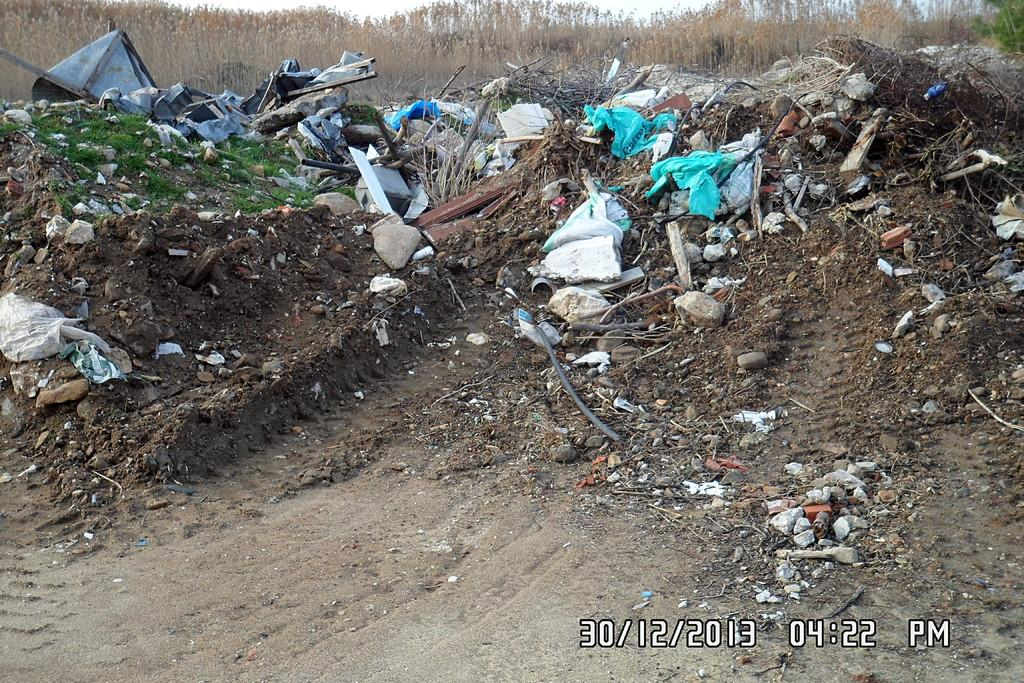What is covering the ground in the image? The ground in the image is covered with dust-like pieces of cloth. What is protecting the ground from the dust-like pieces of cloth? There is a plastic cover on the ground. What else can be found on the ground in the image? Stones and other unwanted waste material are visible on the ground. What can be seen in the background of the image? There are trees in the background of the image. What type of collar is visible on the trees in the image? There is no collar present on the trees in the image. What frame is used to display the stones in the image? There is no frame present in the image; the stones are simply lying on the ground. 